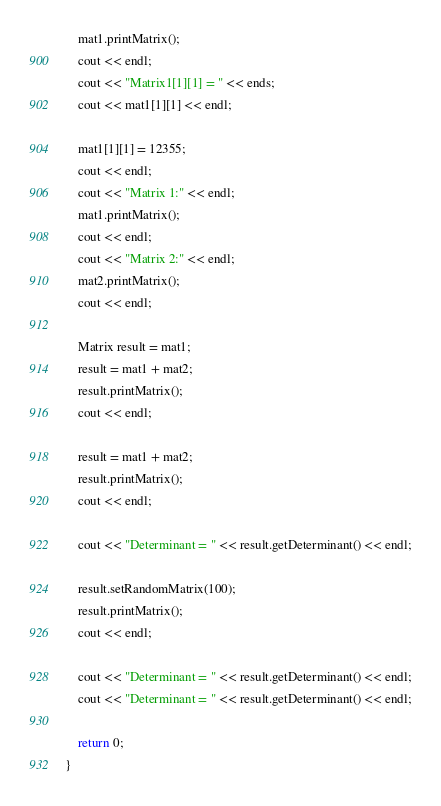Convert code to text. <code><loc_0><loc_0><loc_500><loc_500><_C++_>	mat1.printMatrix();
	cout << endl;
	cout << "Matrix1[1][1] = " << ends;
	cout << mat1[1][1] << endl;

	mat1[1][1] = 12355;
	cout << endl;
	cout << "Matrix 1:" << endl;
	mat1.printMatrix();
	cout << endl;
	cout << "Matrix 2:" << endl;
	mat2.printMatrix();
	cout << endl;

	Matrix result = mat1;
	result = mat1 + mat2;
	result.printMatrix();
	cout << endl;

	result = mat1 + mat2;
	result.printMatrix();
	cout << endl;

	cout << "Determinant = " << result.getDeterminant() << endl;

	result.setRandomMatrix(100);
	result.printMatrix();
	cout << endl;

	cout << "Determinant = " << result.getDeterminant() << endl;
	cout << "Determinant = " << result.getDeterminant() << endl;

	return 0;
}</code> 